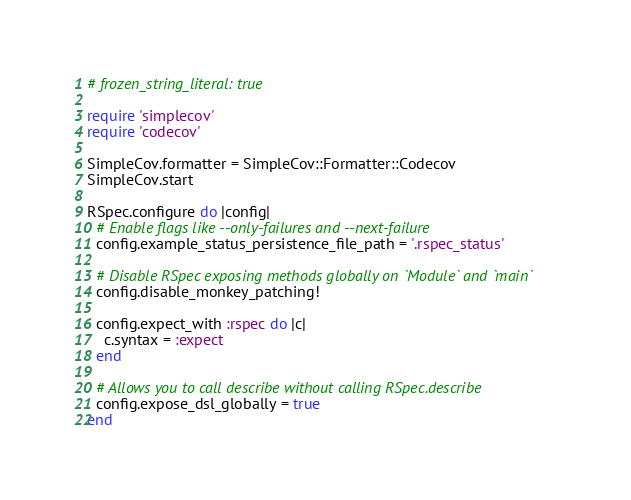<code> <loc_0><loc_0><loc_500><loc_500><_Ruby_># frozen_string_literal: true

require 'simplecov'
require 'codecov'

SimpleCov.formatter = SimpleCov::Formatter::Codecov
SimpleCov.start

RSpec.configure do |config|
  # Enable flags like --only-failures and --next-failure
  config.example_status_persistence_file_path = '.rspec_status'

  # Disable RSpec exposing methods globally on `Module` and `main`
  config.disable_monkey_patching!

  config.expect_with :rspec do |c|
    c.syntax = :expect
  end

  # Allows you to call describe without calling RSpec.describe
  config.expose_dsl_globally = true
end
</code> 